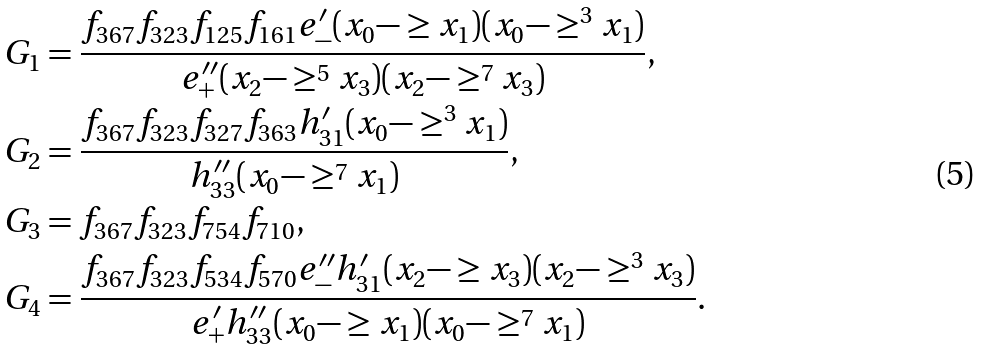<formula> <loc_0><loc_0><loc_500><loc_500>& G _ { 1 } = \frac { f _ { 3 6 7 } f _ { 3 2 3 } f _ { 1 2 5 } f _ { 1 6 1 } e ^ { \prime } _ { - } ( x _ { 0 } - \geq x _ { 1 } ) ( x _ { 0 } - \geq ^ { 3 } x _ { 1 } ) } { e ^ { \prime \prime } _ { + } ( x _ { 2 } - \geq ^ { 5 } x _ { 3 } ) ( x _ { 2 } - \geq ^ { 7 } x _ { 3 } ) } , \\ & G _ { 2 } = \frac { f _ { 3 6 7 } f _ { 3 2 3 } f _ { 3 2 7 } f _ { 3 6 3 } h ^ { \prime } _ { 3 1 } ( x _ { 0 } - \geq ^ { 3 } x _ { 1 } ) } { h ^ { \prime \prime } _ { 3 3 } ( x _ { 0 } - \geq ^ { 7 } x _ { 1 } ) } , \\ & G _ { 3 } = f _ { 3 6 7 } f _ { 3 2 3 } f _ { 7 5 4 } f _ { 7 1 0 } , \\ & G _ { 4 } = \frac { f _ { 3 6 7 } f _ { 3 2 3 } f _ { 5 3 4 } f _ { 5 7 0 } e ^ { \prime \prime } _ { - } h ^ { \prime } _ { 3 1 } ( x _ { 2 } - \geq x _ { 3 } ) ( x _ { 2 } - \geq ^ { 3 } x _ { 3 } ) } { e ^ { \prime } _ { + } h ^ { \prime \prime } _ { 3 3 } ( x _ { 0 } - \geq x _ { 1 } ) ( x _ { 0 } - \geq ^ { 7 } x _ { 1 } ) } .</formula> 